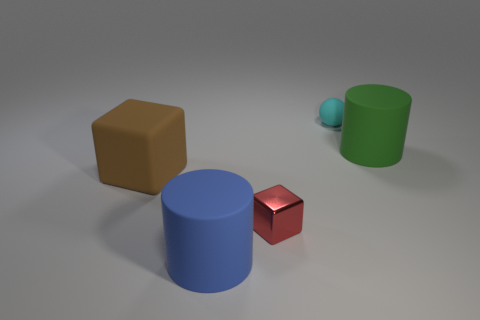Add 2 small purple matte balls. How many objects exist? 7 Subtract all green cylinders. Subtract all red cubes. How many cylinders are left? 1 Subtract all brown cylinders. How many brown balls are left? 0 Subtract all small cyan shiny things. Subtract all blue objects. How many objects are left? 4 Add 1 small matte balls. How many small matte balls are left? 2 Add 1 big yellow cylinders. How many big yellow cylinders exist? 1 Subtract all red blocks. How many blocks are left? 1 Subtract 0 green spheres. How many objects are left? 5 Subtract all cylinders. How many objects are left? 3 Subtract 2 blocks. How many blocks are left? 0 